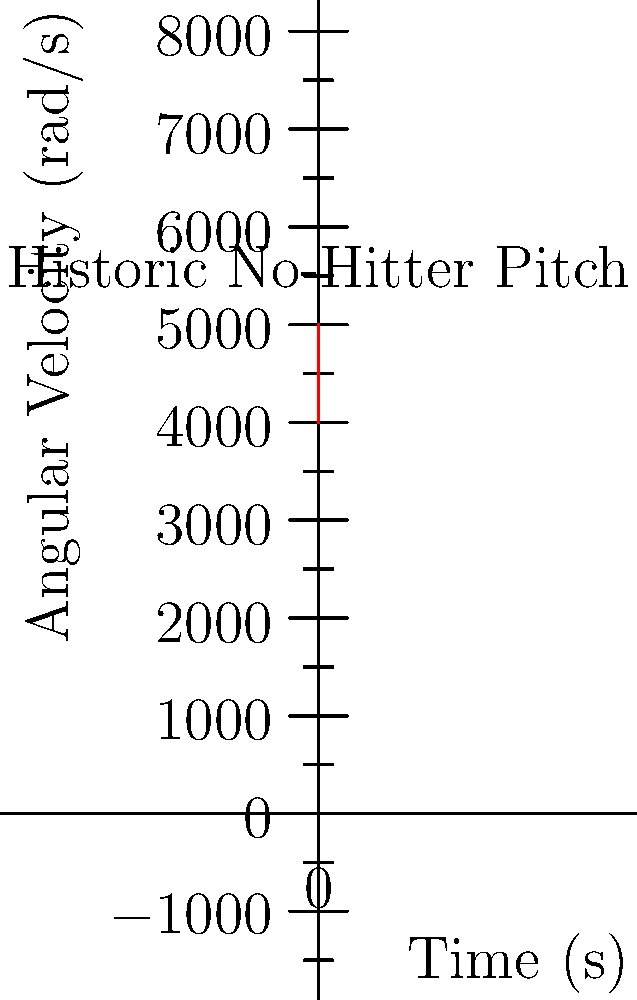In Nolan Ryan's seventh no-hitter on May 1, 1991, his fastball was known for its incredible spin rate. Given the graph showing the angular velocity of his pitch over time, what was the average rate of change in angular velocity during the flight of the ball? To find the average rate of change in angular velocity, we need to follow these steps:

1. Identify the initial and final angular velocities:
   Initial velocity (w₁) = 5000 rad/s at t₁ = 0 s
   Final velocity (w₂) = 4000 rad/s at t₂ = 1.0 s

2. Calculate the change in angular velocity:
   Δw = w₂ - w₁ = 4000 - 5000 = -1000 rad/s

3. Calculate the change in time:
   Δt = t₂ - t₁ = 1.0 - 0 = 1.0 s

4. Apply the formula for average rate of change:
   Average rate of change = Δw / Δt
   
   $$ \text{Average rate of change} = \frac{-1000 \text{ rad/s}}{1.0 \text{ s}} = -1000 \text{ rad/s²} $$

Therefore, the average rate of change in angular velocity during the flight of the ball was -1000 rad/s².
Answer: -1000 rad/s² 